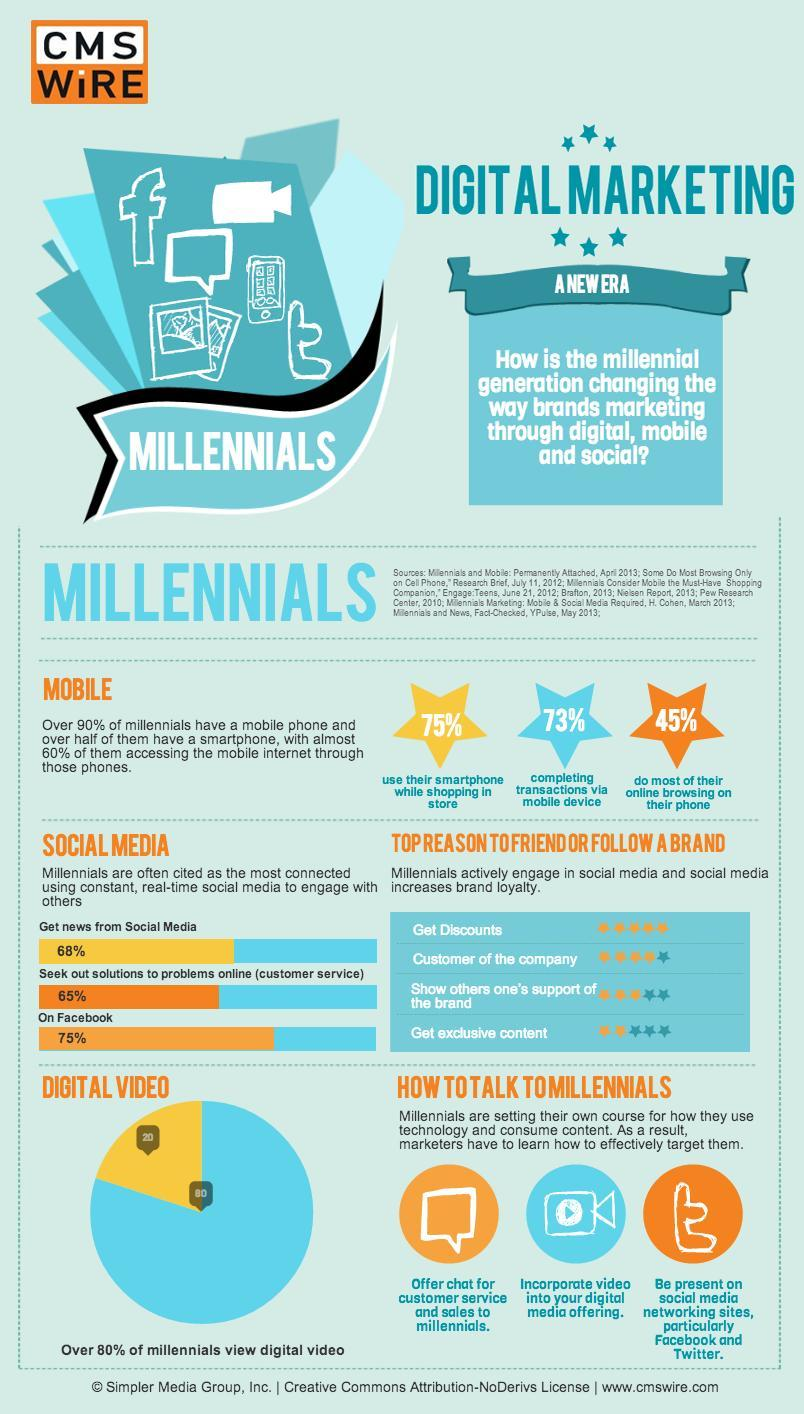How many millennial's go for smartphone while shopping online?
Answer the question with a short phrase. 75% How many star ratings are given for "Get exclusive content"? 2 What is the inverse of the percentage of millennial's who use social media for getting news? 32 What percentage of millennial's are not on Facebook? 25 What percentage of millennial's are not interested in digital videos? 20 What percentage of millennial's do their all kind of surfing through phone? 45% 